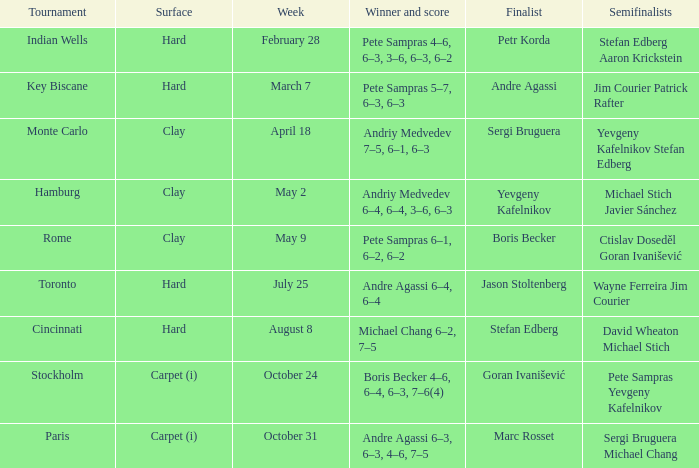Who made it to the semi-final stage of the key biscane event? Jim Courier Patrick Rafter. 